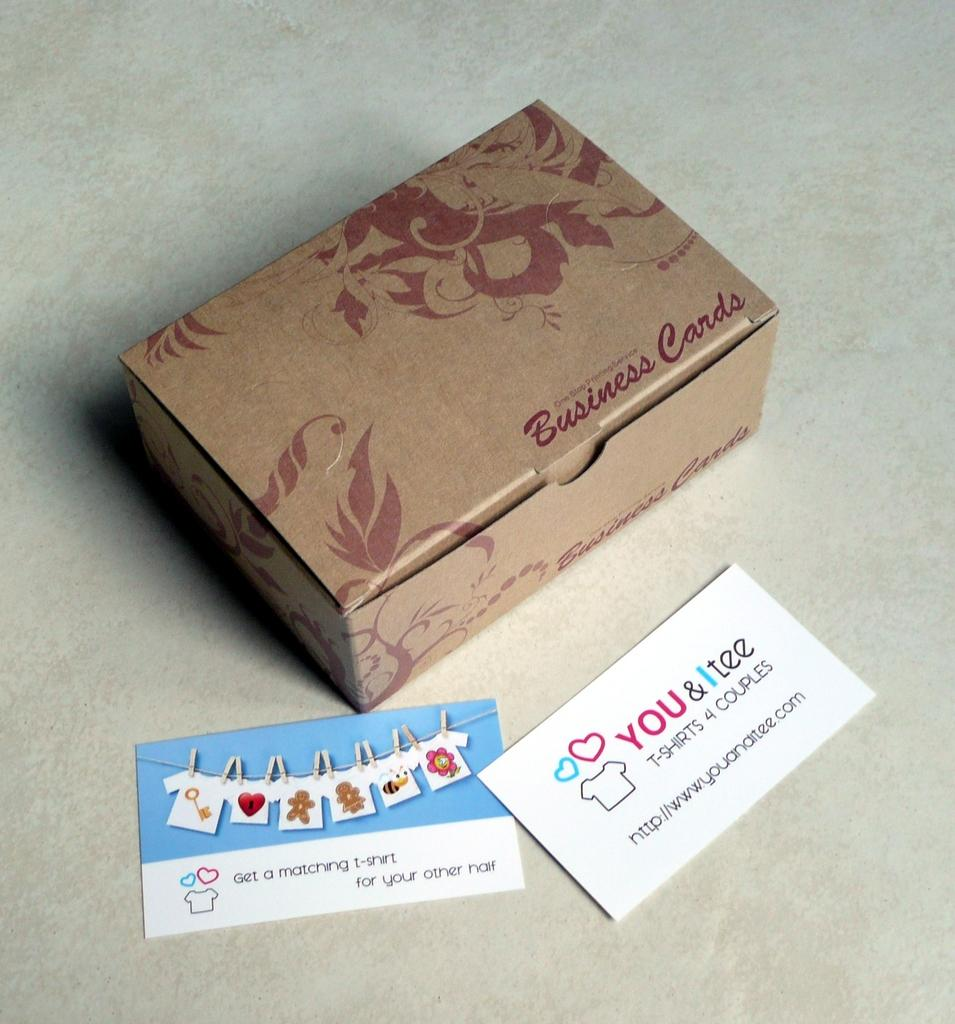Provide a one-sentence caption for the provided image. A business card box with two business cards laying in front of it. 